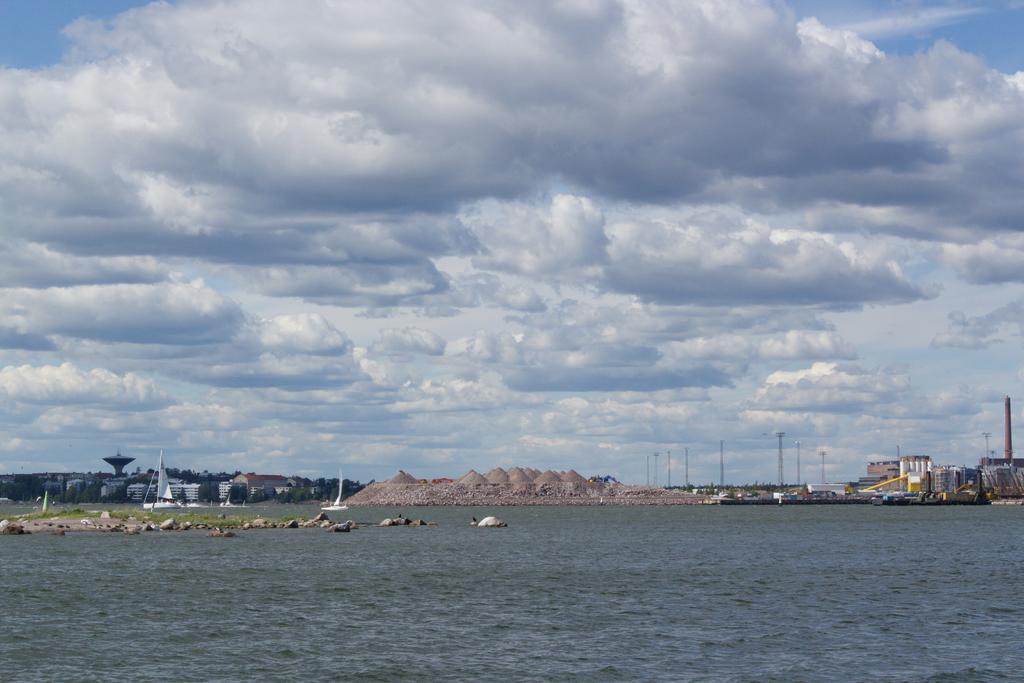Could you give a brief overview of what you see in this image? In this image we can see some buildings, poles, rocks, mountains and other objects. At the top of the image there is the sky. At the bottom of the image there is water. 